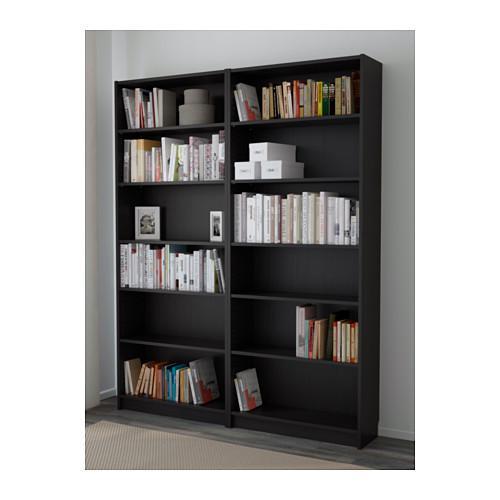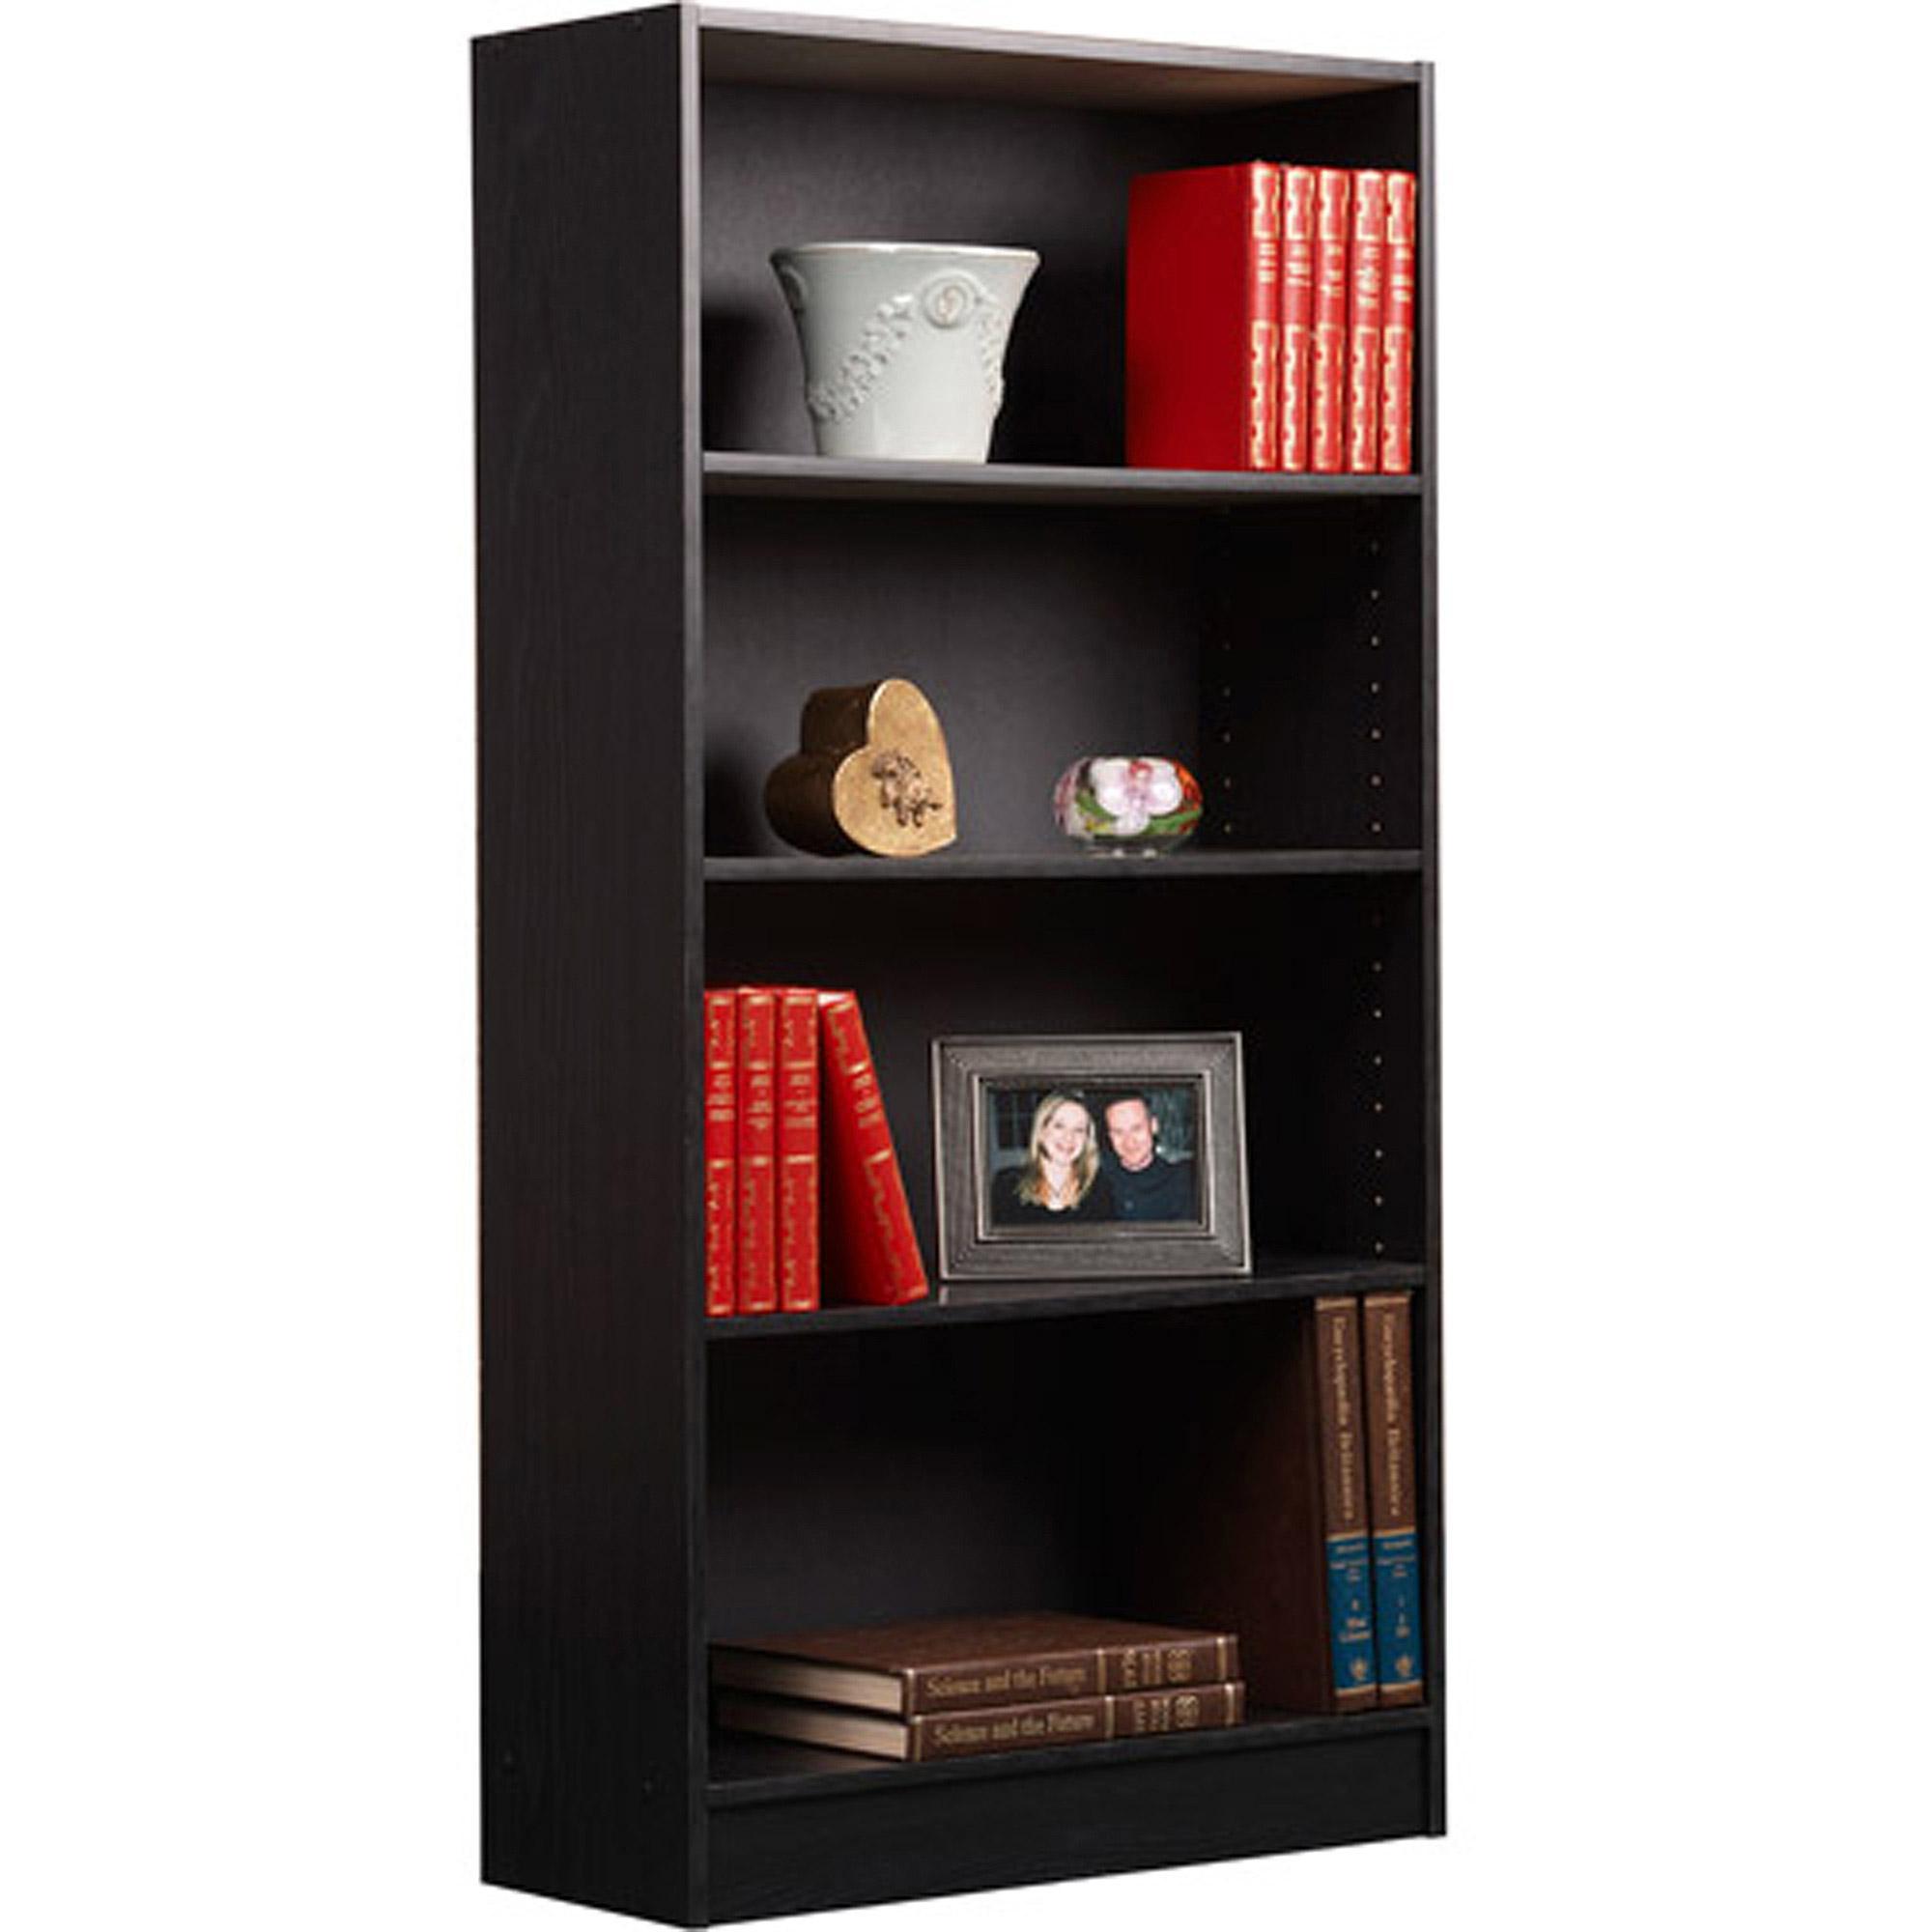The first image is the image on the left, the second image is the image on the right. For the images shown, is this caption "There is a white pail shaped vase on a shelf." true? Answer yes or no. Yes. 